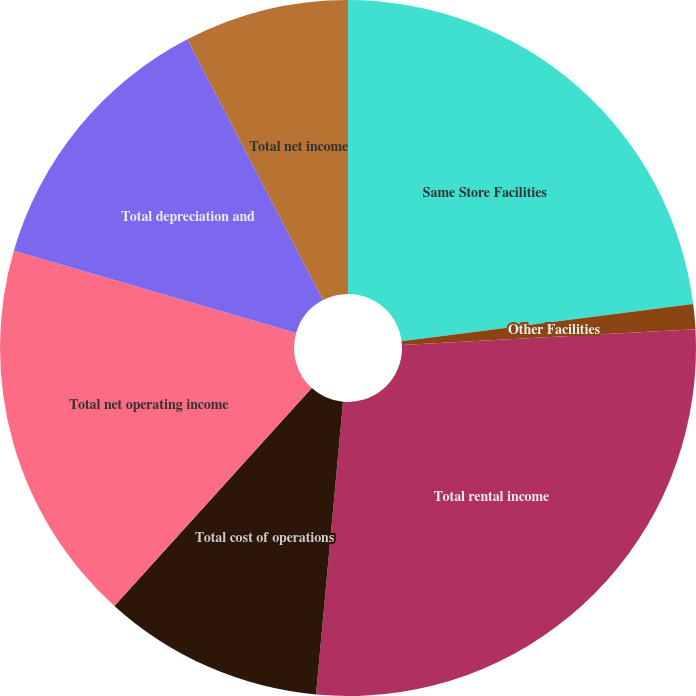Convert chart to OTSL. <chart><loc_0><loc_0><loc_500><loc_500><pie_chart><fcel>Same Store Facilities<fcel>Other Facilities<fcel>Total rental income<fcel>Total cost of operations<fcel>Total net operating income<fcel>Total depreciation and<fcel>Total net income<nl><fcel>22.98%<fcel>1.17%<fcel>27.32%<fcel>10.25%<fcel>17.79%<fcel>12.86%<fcel>7.64%<nl></chart> 